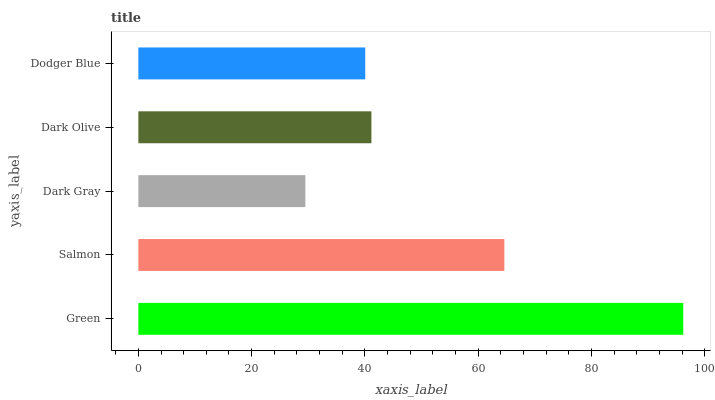Is Dark Gray the minimum?
Answer yes or no. Yes. Is Green the maximum?
Answer yes or no. Yes. Is Salmon the minimum?
Answer yes or no. No. Is Salmon the maximum?
Answer yes or no. No. Is Green greater than Salmon?
Answer yes or no. Yes. Is Salmon less than Green?
Answer yes or no. Yes. Is Salmon greater than Green?
Answer yes or no. No. Is Green less than Salmon?
Answer yes or no. No. Is Dark Olive the high median?
Answer yes or no. Yes. Is Dark Olive the low median?
Answer yes or no. Yes. Is Dodger Blue the high median?
Answer yes or no. No. Is Dark Gray the low median?
Answer yes or no. No. 